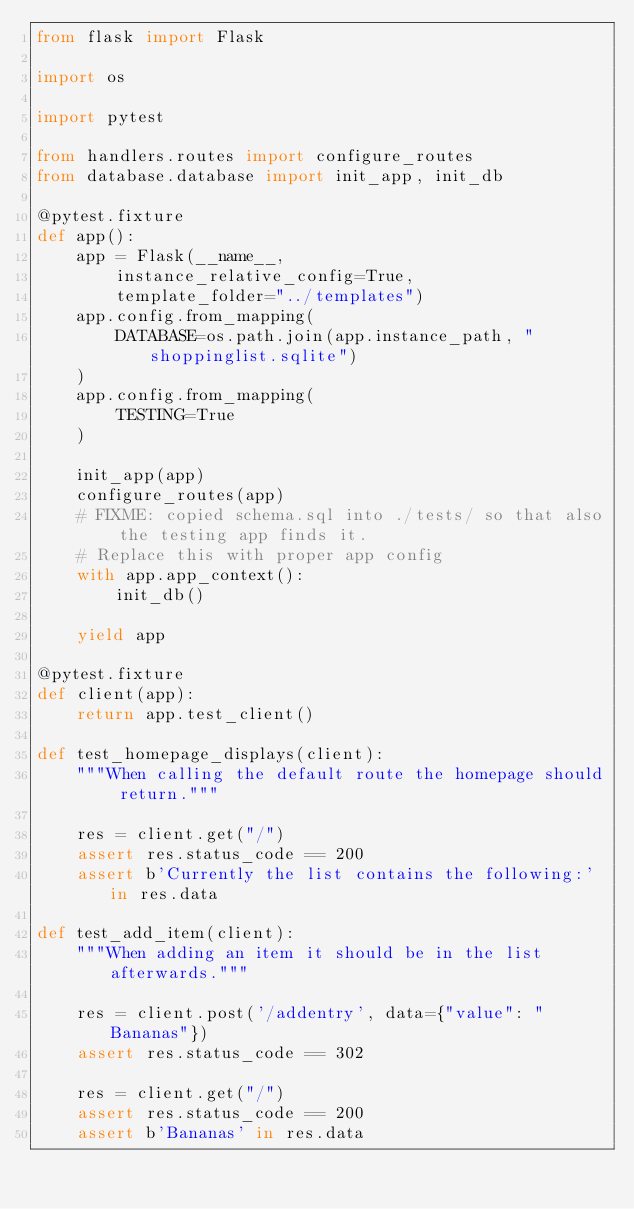Convert code to text. <code><loc_0><loc_0><loc_500><loc_500><_Python_>from flask import Flask

import os

import pytest

from handlers.routes import configure_routes
from database.database import init_app, init_db

@pytest.fixture
def app():
    app = Flask(__name__, 
        instance_relative_config=True, 
        template_folder="../templates")
    app.config.from_mapping(
        DATABASE=os.path.join(app.instance_path, "shoppinglist.sqlite")
    )
    app.config.from_mapping(
        TESTING=True
    )
    
    init_app(app)
    configure_routes(app)
    # FIXME: copied schema.sql into ./tests/ so that also the testing app finds it. 
    # Replace this with proper app config
    with app.app_context():
        init_db()

    yield app

@pytest.fixture
def client(app):
    return app.test_client()

def test_homepage_displays(client):
    """When calling the default route the homepage should return."""

    res = client.get("/")
    assert res.status_code == 200
    assert b'Currently the list contains the following:' in res.data

def test_add_item(client):
    """When adding an item it should be in the list afterwards."""

    res = client.post('/addentry', data={"value": "Bananas"})
    assert res.status_code == 302

    res = client.get("/")
    assert res.status_code == 200
    assert b'Bananas' in res.data
</code> 